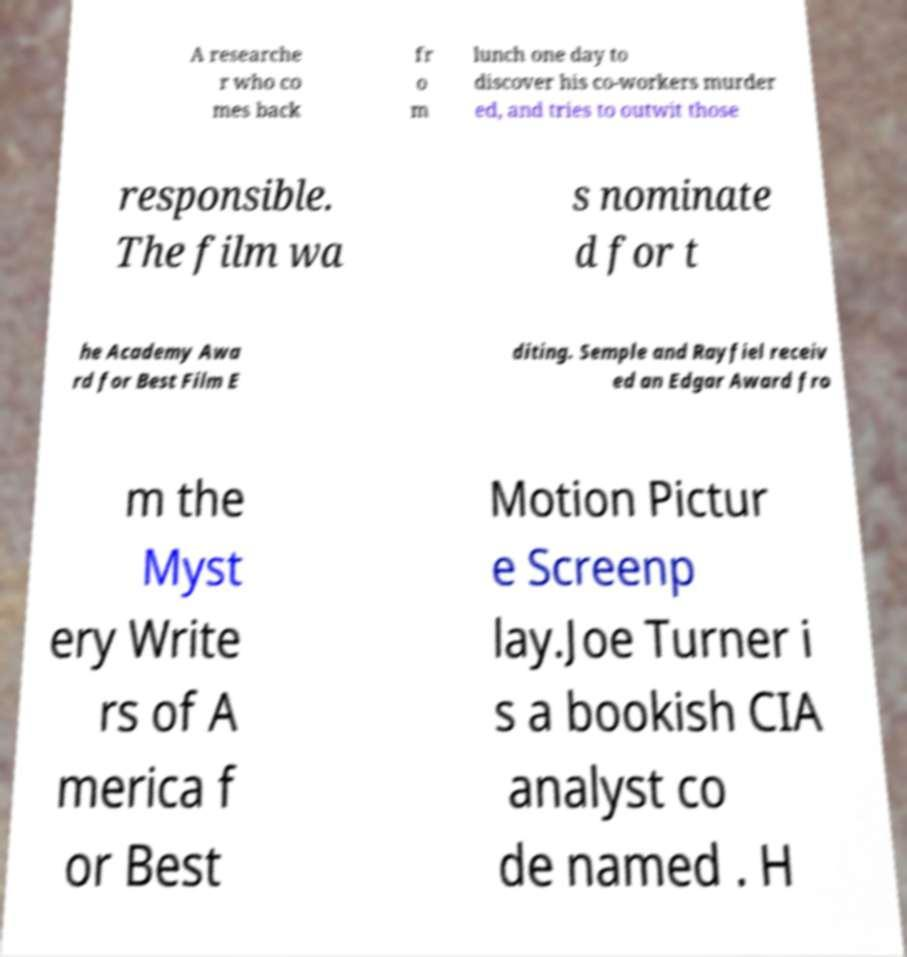For documentation purposes, I need the text within this image transcribed. Could you provide that? A researche r who co mes back fr o m lunch one day to discover his co-workers murder ed, and tries to outwit those responsible. The film wa s nominate d for t he Academy Awa rd for Best Film E diting. Semple and Rayfiel receiv ed an Edgar Award fro m the Myst ery Write rs of A merica f or Best Motion Pictur e Screenp lay.Joe Turner i s a bookish CIA analyst co de named . H 